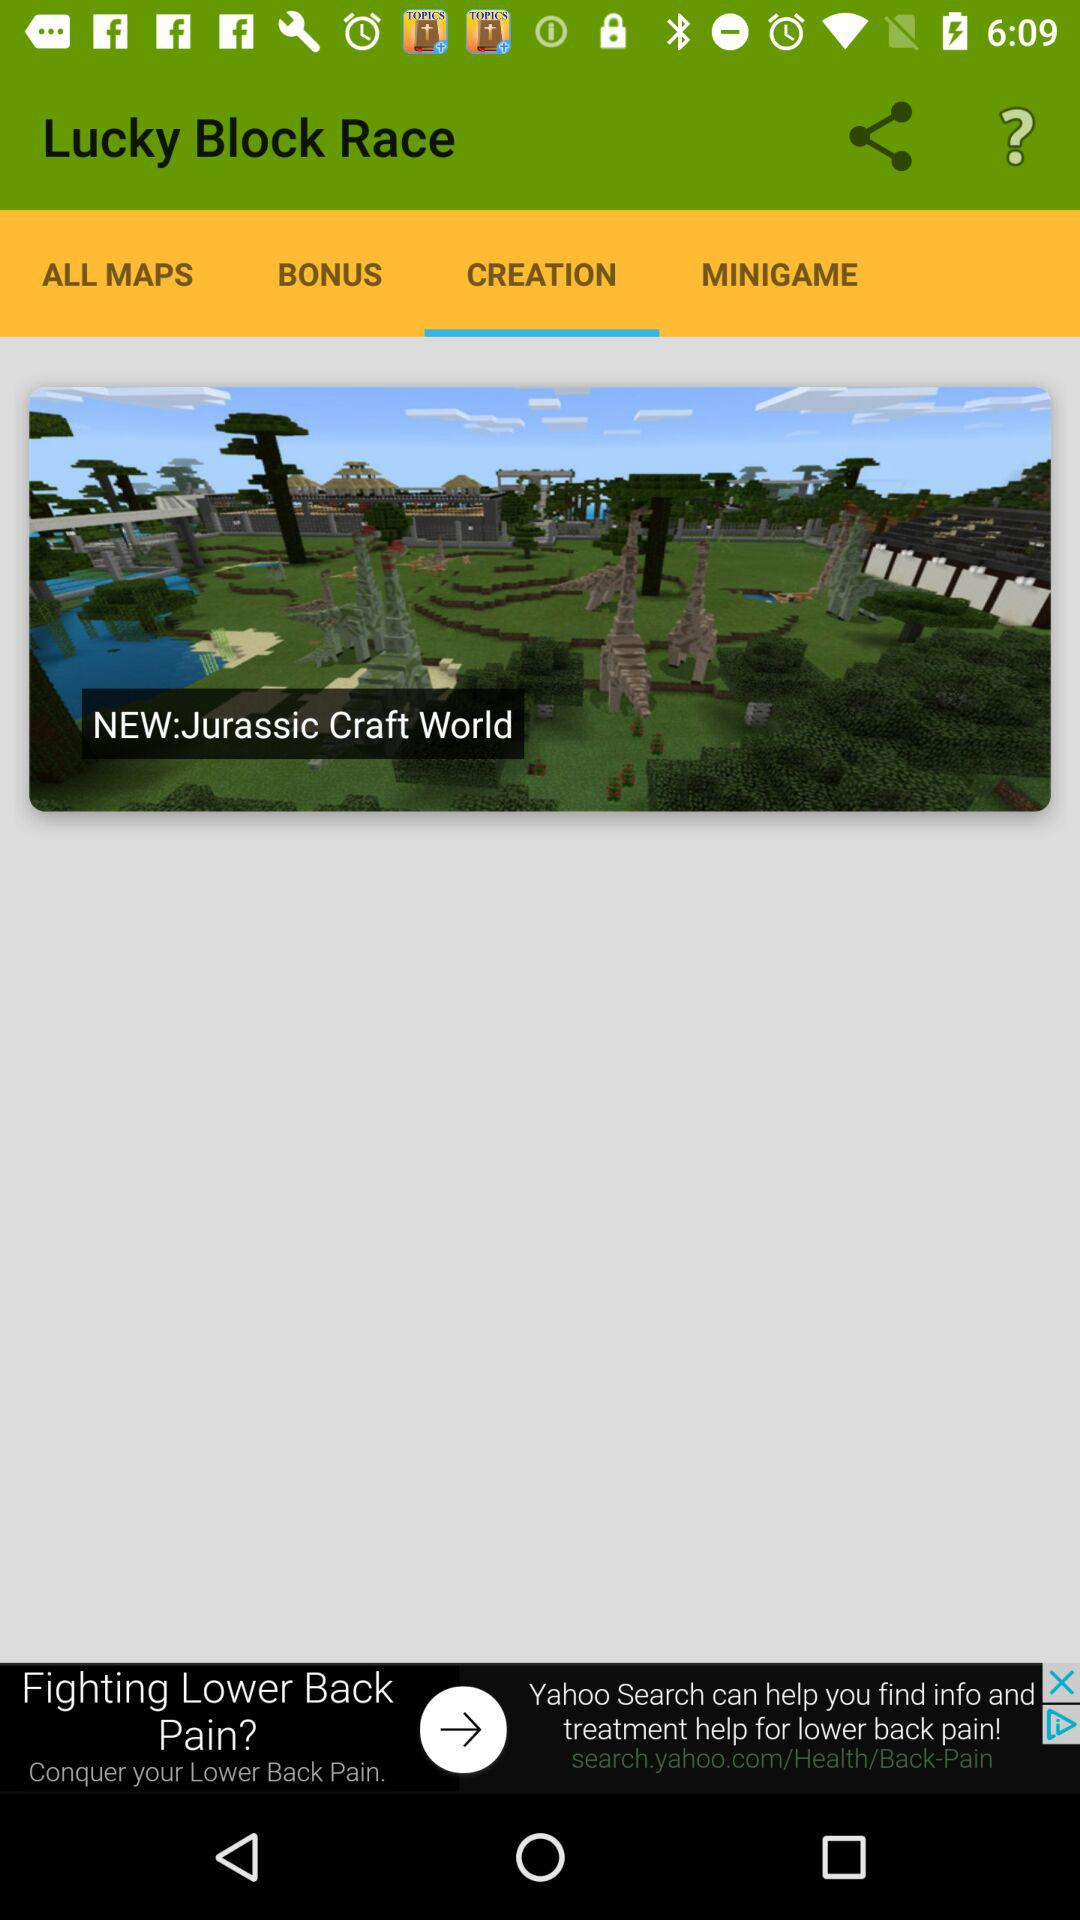What is the name of the application? The name of the application is "Lucky Block Race". 